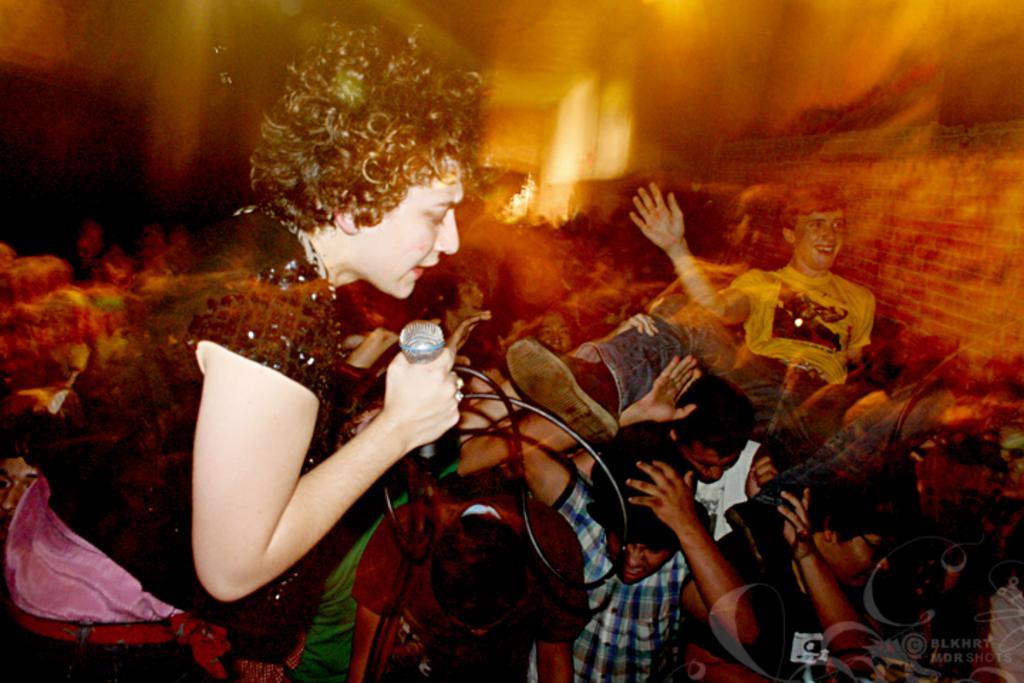Describe this image in one or two sentences. In this image we can see some group of kids standing and a woman wearing black color dress holding microphone in her hands and in the background image is blur. 